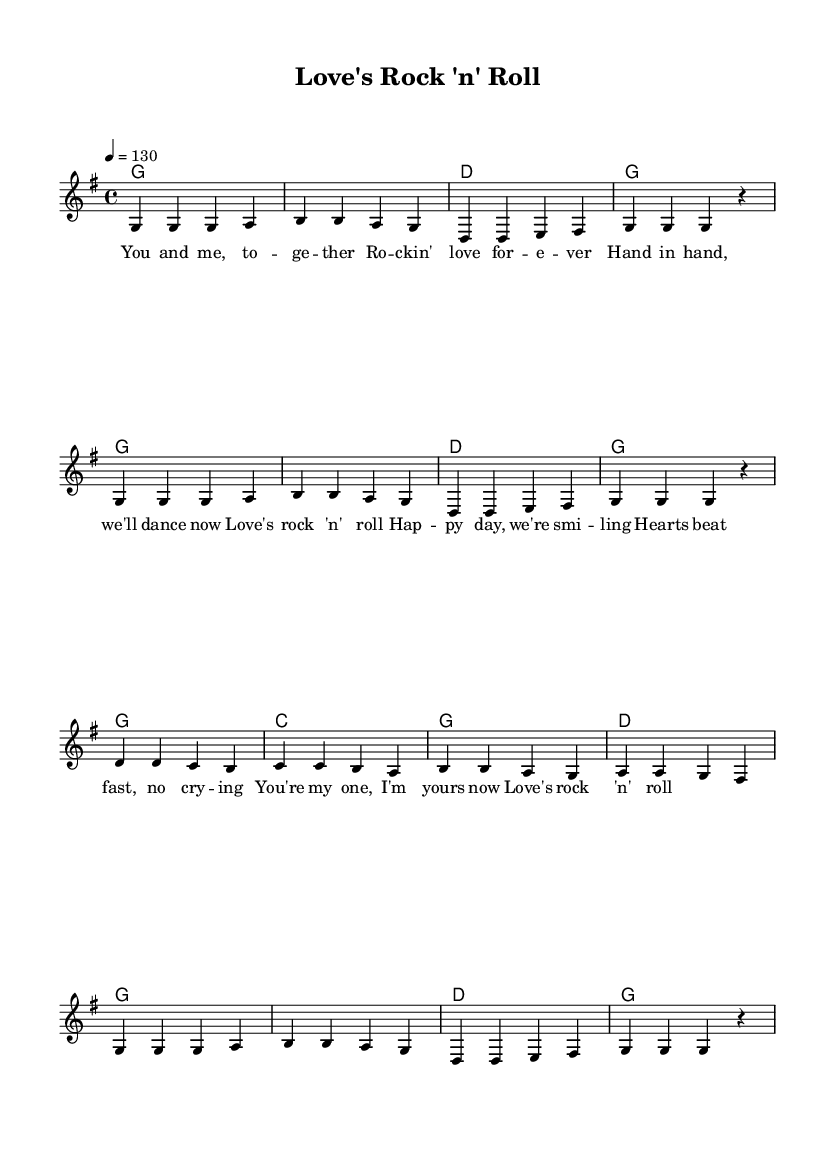What is the key signature of this music? The key signature is G major, which has one sharp (F#). This can be determined by looking at the number of sharps indicated in the key signature section of the sheet music.
Answer: G major What is the time signature of this music? The time signature is 4/4, indicating that there are four beats in each measure and the quarter note receives one beat. This is indicated at the beginning of the sheet music.
Answer: 4/4 What is the tempo of this music? The tempo is 130 beats per minute, as indicated by the marking showing the tempo at the top of the music. This means the tempo at which the music should be played.
Answer: 130 How many measures are in the verse? The verse consists of 8 measures, as counted by looking at the section of the music where the lyrics are aligned with the melody. Each line typically has four measures, and there are two lines.
Answer: 8 What chords are primarily used in this song? The primary chords used in this song are G, D, and C. These chords are indicated in the harmony section of the sheet music where the chord symbols above the staff are shown.
Answer: G, D, C What is the overall mood of this song based on its style? The overall mood is upbeat and joyful, characteristic of rock music which typically has a lively rhythm and energetic feel. This is inferred from both the upbeat tempo and the happy lyrics.
Answer: Upbeat 